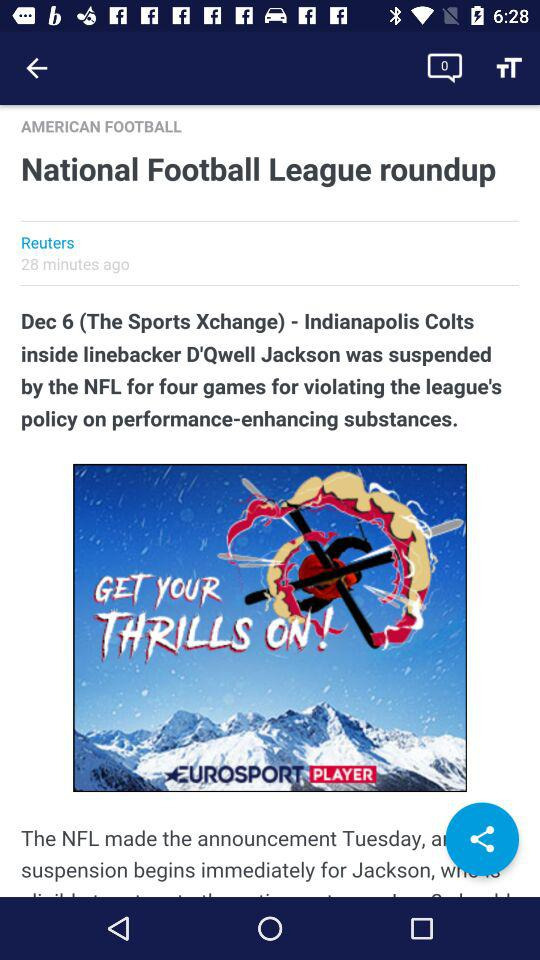What is the date of the Sports Xchange? The date is December 6. 